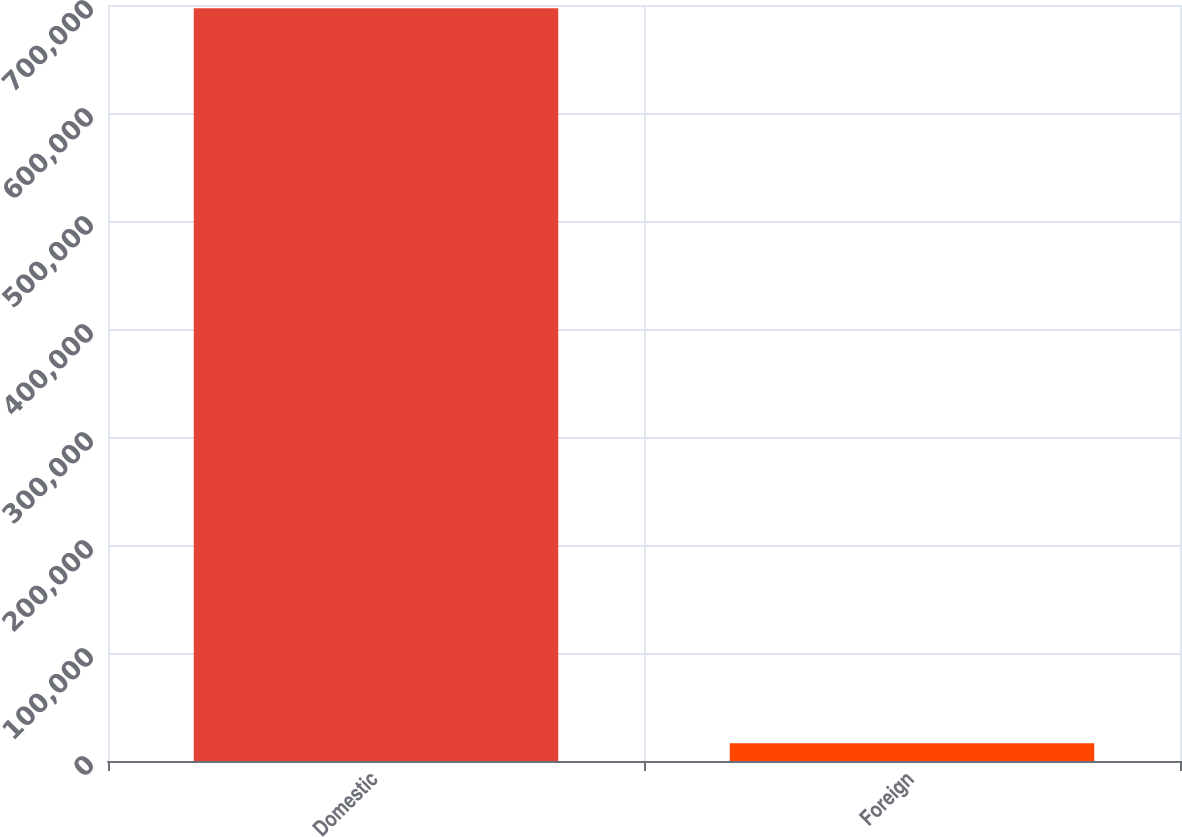Convert chart. <chart><loc_0><loc_0><loc_500><loc_500><bar_chart><fcel>Domestic<fcel>Foreign<nl><fcel>697062<fcel>16406<nl></chart> 